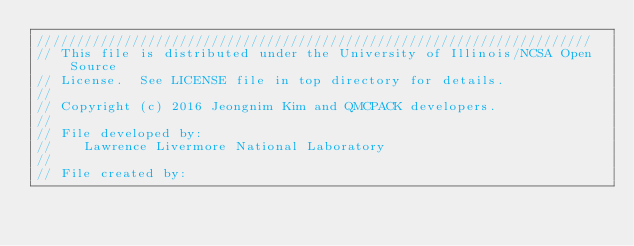<code> <loc_0><loc_0><loc_500><loc_500><_Cuda_>//////////////////////////////////////////////////////////////////////
// This file is distributed under the University of Illinois/NCSA Open Source
// License.  See LICENSE file in top directory for details.
//
// Copyright (c) 2016 Jeongnim Kim and QMCPACK developers.
//
// File developed by:
//    Lawrence Livermore National Laboratory 
//
// File created by:</code> 